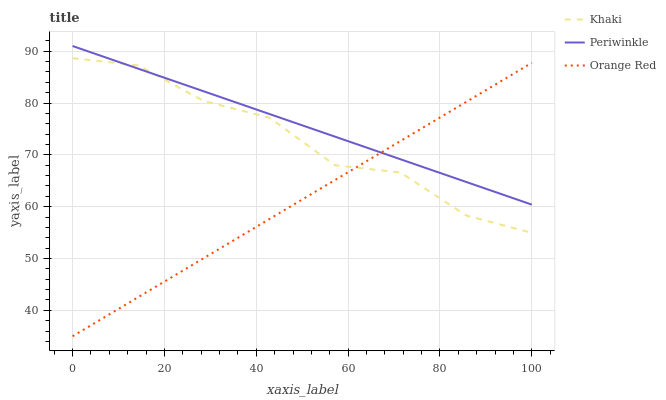Does Orange Red have the minimum area under the curve?
Answer yes or no. Yes. Does Periwinkle have the maximum area under the curve?
Answer yes or no. Yes. Does Periwinkle have the minimum area under the curve?
Answer yes or no. No. Does Orange Red have the maximum area under the curve?
Answer yes or no. No. Is Orange Red the smoothest?
Answer yes or no. Yes. Is Khaki the roughest?
Answer yes or no. Yes. Is Periwinkle the smoothest?
Answer yes or no. No. Is Periwinkle the roughest?
Answer yes or no. No. Does Orange Red have the lowest value?
Answer yes or no. Yes. Does Periwinkle have the lowest value?
Answer yes or no. No. Does Periwinkle have the highest value?
Answer yes or no. Yes. Does Orange Red have the highest value?
Answer yes or no. No. Does Periwinkle intersect Khaki?
Answer yes or no. Yes. Is Periwinkle less than Khaki?
Answer yes or no. No. Is Periwinkle greater than Khaki?
Answer yes or no. No. 